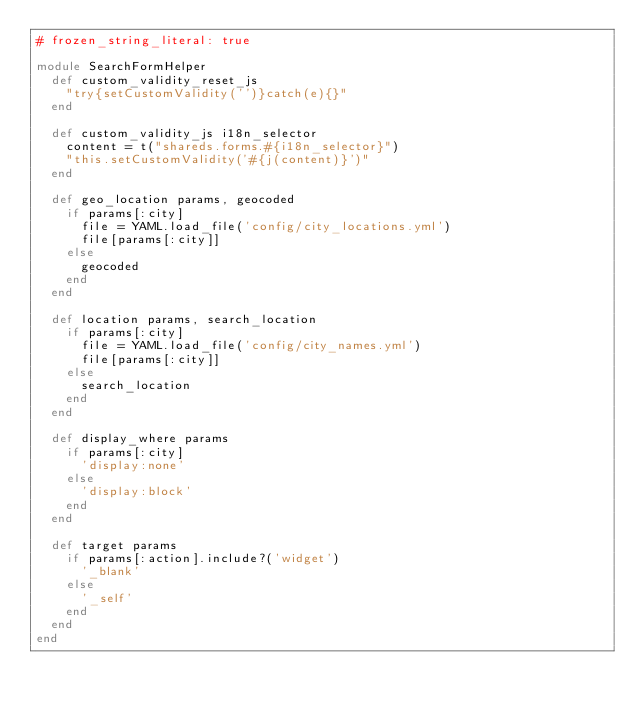Convert code to text. <code><loc_0><loc_0><loc_500><loc_500><_Ruby_># frozen_string_literal: true

module SearchFormHelper
  def custom_validity_reset_js
    "try{setCustomValidity('')}catch(e){}"
  end

  def custom_validity_js i18n_selector
    content = t("shareds.forms.#{i18n_selector}")
    "this.setCustomValidity('#{j(content)}')"
  end

  def geo_location params, geocoded
    if params[:city]
      file = YAML.load_file('config/city_locations.yml')
      file[params[:city]]
    else
      geocoded
    end
  end

  def location params, search_location
    if params[:city]
      file = YAML.load_file('config/city_names.yml')
      file[params[:city]]
    else
      search_location
    end
  end

  def display_where params
    if params[:city]
      'display:none'
    else
      'display:block'
    end
  end

  def target params
    if params[:action].include?('widget')
      '_blank'
    else
      '_self'
    end
  end
end
</code> 